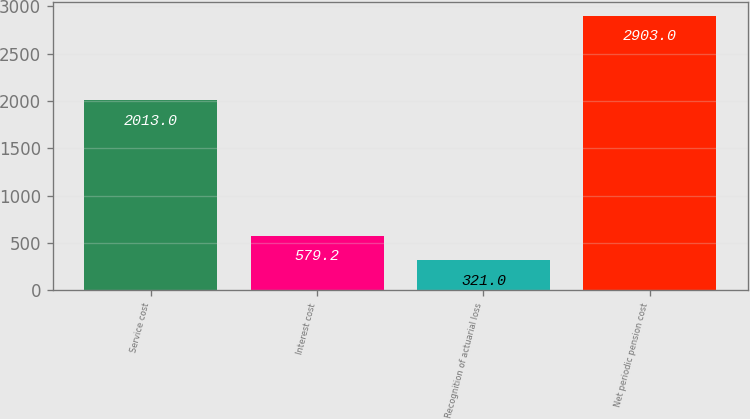<chart> <loc_0><loc_0><loc_500><loc_500><bar_chart><fcel>Service cost<fcel>Interest cost<fcel>Recognition of actuarial loss<fcel>Net periodic pension cost<nl><fcel>2013<fcel>579.2<fcel>321<fcel>2903<nl></chart> 